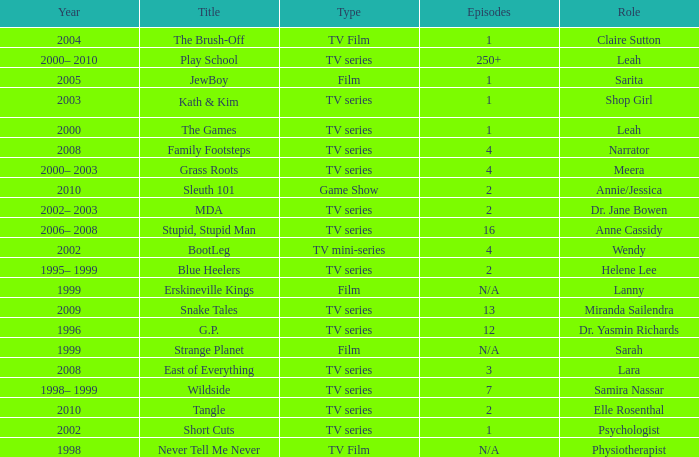What episode is called jewboy 1.0. 